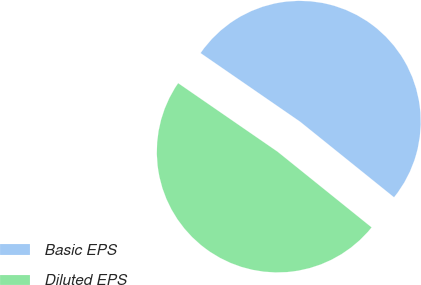<chart> <loc_0><loc_0><loc_500><loc_500><pie_chart><fcel>Basic EPS<fcel>Diluted EPS<nl><fcel>51.18%<fcel>48.82%<nl></chart> 